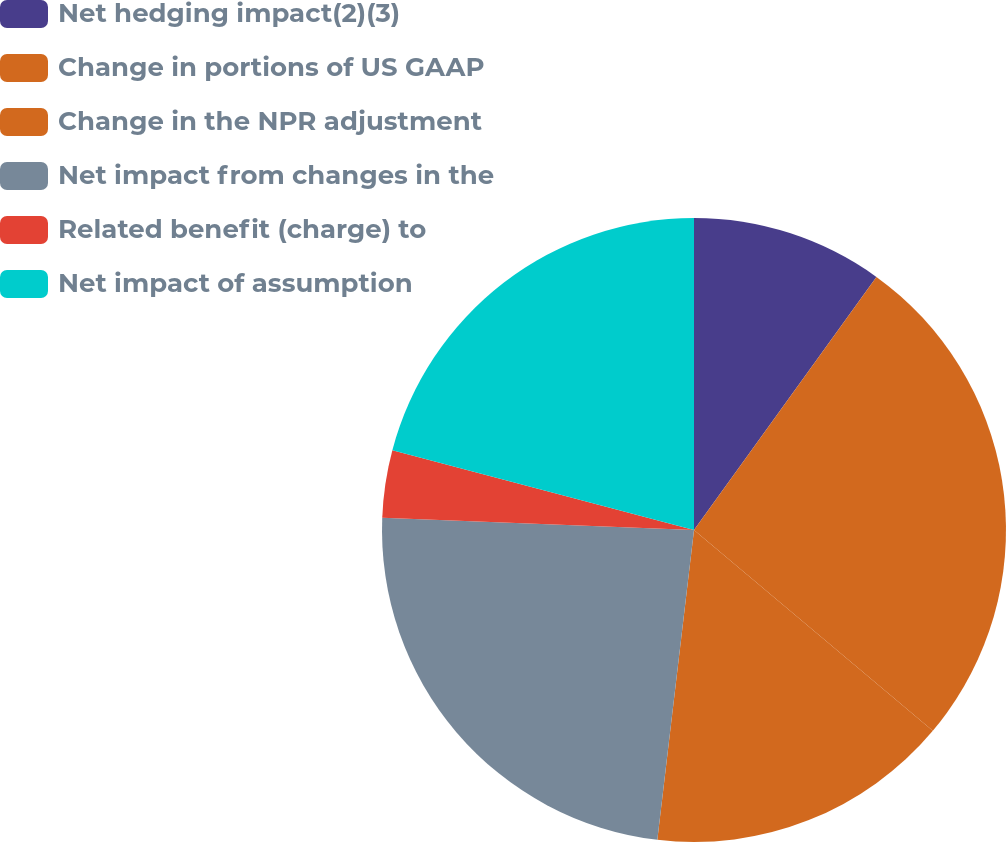Convert chart to OTSL. <chart><loc_0><loc_0><loc_500><loc_500><pie_chart><fcel>Net hedging impact(2)(3)<fcel>Change in portions of US GAAP<fcel>Change in the NPR adjustment<fcel>Net impact from changes in the<fcel>Related benefit (charge) to<fcel>Net impact of assumption<nl><fcel>9.94%<fcel>26.19%<fcel>15.75%<fcel>23.75%<fcel>3.49%<fcel>20.89%<nl></chart> 